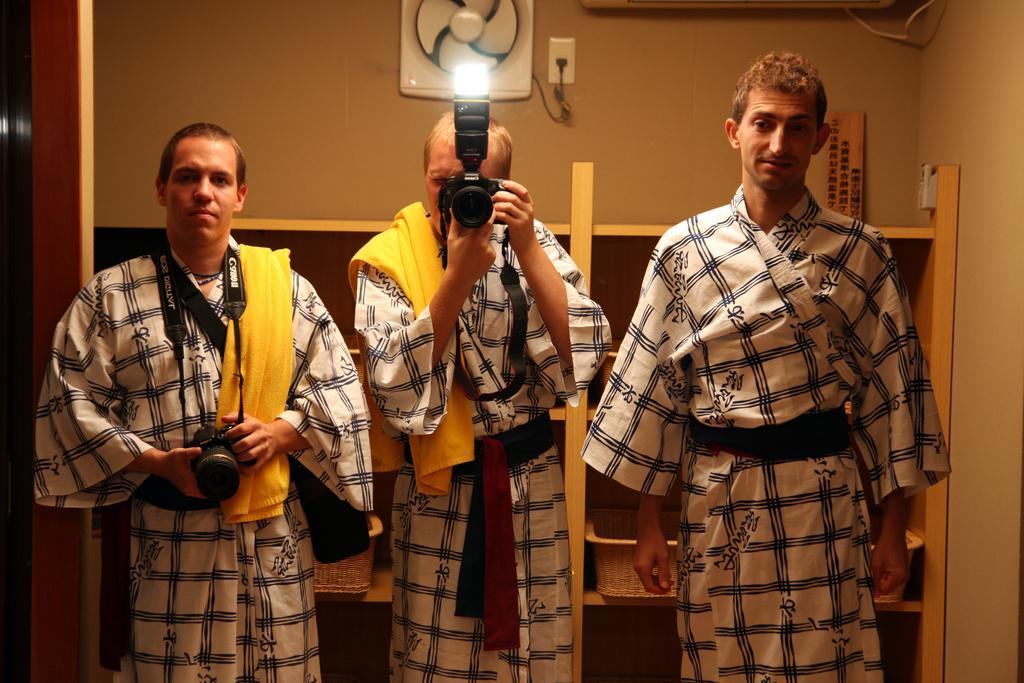How would you summarize this image in a sentence or two? In the image there are three people standing in the foreground and the first two people are holding cameras, behind them there are wooden shelves and in the background there is a wall. 